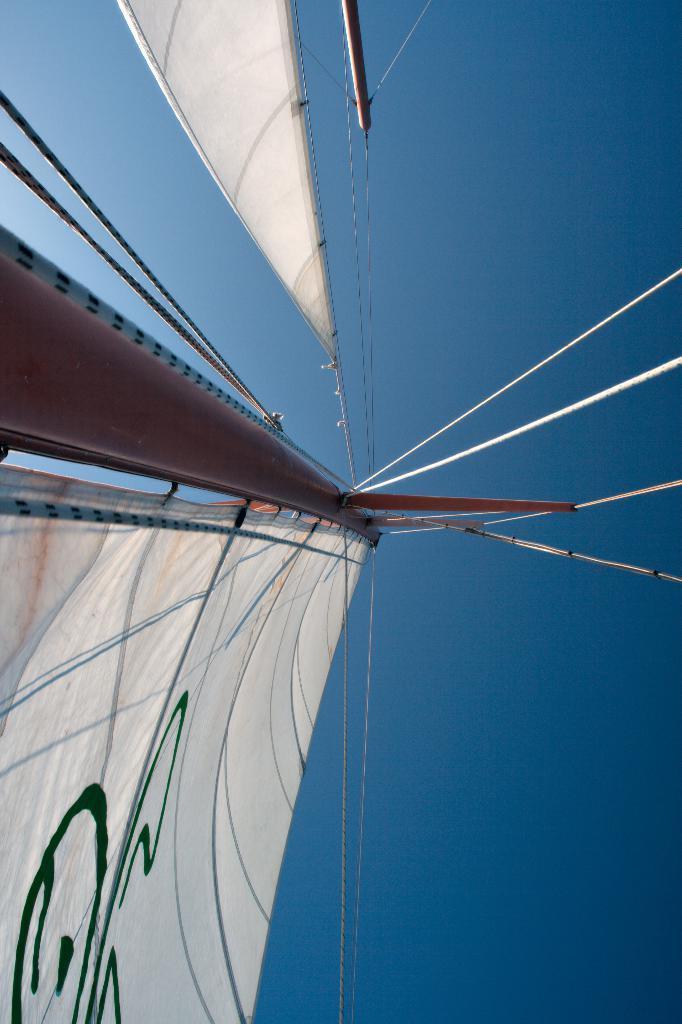In one or two sentences, can you explain what this image depicts? In this image we can see clothes ties to the pole and rope and we can see ropes, poles and sky. 